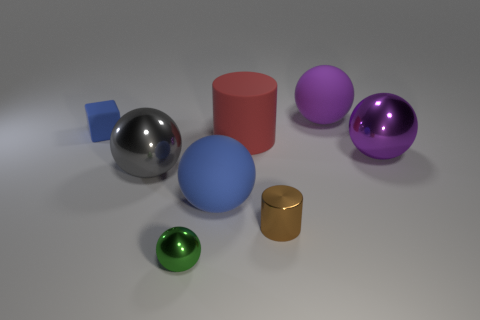Are there more big blue rubber balls than small gray cylinders?
Keep it short and to the point. Yes. How many other things are the same material as the large blue sphere?
Give a very brief answer. 3. What shape is the matte thing that is to the right of the tiny metal thing on the right side of the tiny metallic thing that is to the left of the tiny brown shiny object?
Your answer should be compact. Sphere. Are there fewer green things that are left of the green sphere than large blue rubber balls in front of the brown cylinder?
Your answer should be compact. No. Is there a tiny cylinder of the same color as the small block?
Your response must be concise. No. Do the large gray sphere and the cylinder that is behind the blue matte ball have the same material?
Ensure brevity in your answer.  No. Are there any blue matte spheres left of the rubber object that is on the left side of the big blue rubber object?
Give a very brief answer. No. There is a object that is both to the right of the red rubber cylinder and behind the big red matte cylinder; what color is it?
Ensure brevity in your answer.  Purple. What size is the blue cube?
Offer a terse response. Small. What number of purple shiny things are the same size as the cube?
Your response must be concise. 0. 